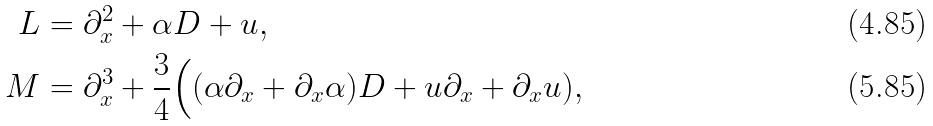<formula> <loc_0><loc_0><loc_500><loc_500>L & = \partial _ { x } ^ { 2 } + \alpha D + u , \\ M & = \partial _ { x } ^ { 3 } + \frac { 3 } { 4 } \Big ( ( \alpha \partial _ { x } + \partial _ { x } \alpha ) D + u \partial _ { x } + \partial _ { x } u ) ,</formula> 